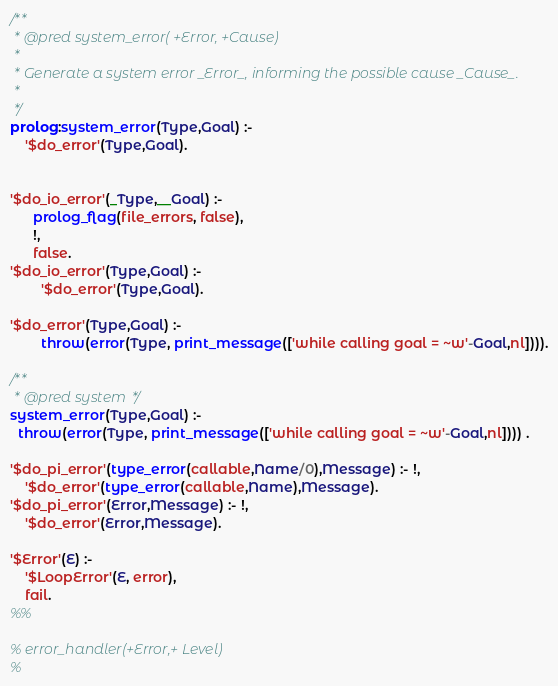Convert code to text. <code><loc_0><loc_0><loc_500><loc_500><_Prolog_>

/**
 * @pred system_error( +Error, +Cause)
 *
 * Generate a system error _Error_, informing the possible cause _Cause_.
 *
 */
prolog:system_error(Type,Goal) :-
    '$do_error'(Type,Goal).


'$do_io_error'(_Type,__Goal) :-
      prolog_flag(file_errors, false),
      !,
      false.
'$do_io_error'(Type,Goal) :-
        '$do_error'(Type,Goal).

'$do_error'(Type,Goal) :-
      	throw(error(Type, print_message(['while calling goal = ~w'-Goal,nl]))).

/**
 * @pred system */
system_error(Type,Goal) :-
  throw(error(Type, print_message(['while calling goal = ~w'-Goal,nl]))) .

'$do_pi_error'(type_error(callable,Name/0),Message) :- !,
	'$do_error'(type_error(callable,Name),Message).
'$do_pi_error'(Error,Message) :- !,
	'$do_error'(Error,Message).

'$Error'(E) :-
    '$LoopError'(E, error),
    fail.
%%

% error_handler(+Error,+ Level)
%</code> 